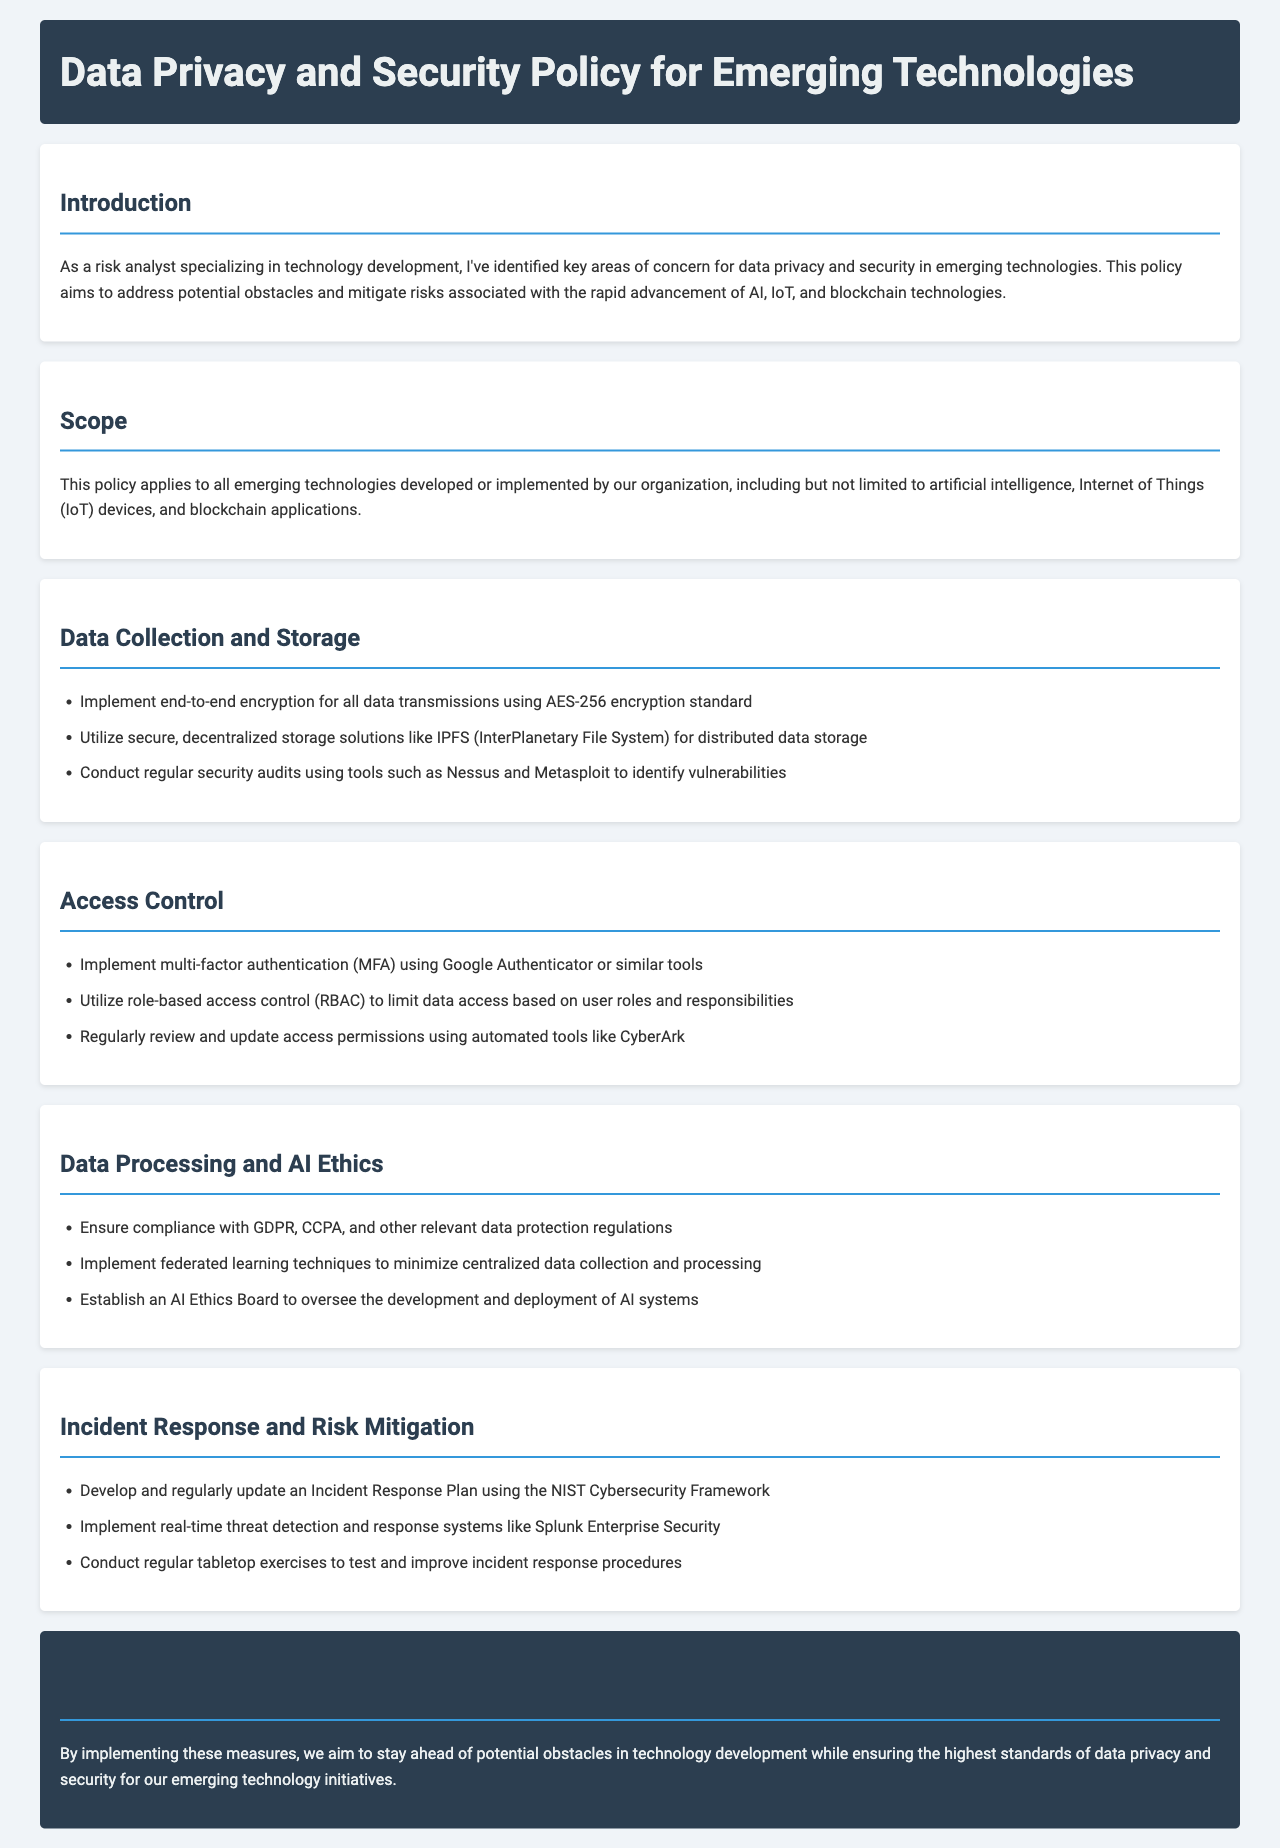what is the main purpose of this policy? The purpose of the policy is to address potential obstacles and mitigate risks associated with the rapid advancement of technologies.
Answer: address potential obstacles and mitigate risks which encryption standard should be used for data transmissions? The document specifies the AES-256 encryption standard for data transmissions.
Answer: AES-256 what types of technology does this policy apply to? The policy applies to technologies such as artificial intelligence, IoT devices, and blockchain applications.
Answer: artificial intelligence, IoT devices, blockchain applications what framework should be used for Incident Response Plans? The NIST Cybersecurity Framework should be used for Incident Response Plans.
Answer: NIST Cybersecurity Framework how often should access permissions be reviewed? The document suggests that access permissions should be reviewed regularly.
Answer: regularly who should oversee the development and deployment of AI systems? An AI Ethics Board is to oversee the development and deployment of AI systems.
Answer: AI Ethics Board what is one tool mentioned for security audits? The document mentions Nessus as a tool for security audits.
Answer: Nessus which technique minimizes centralized data collection in data processing? Federated learning techniques minimize centralized data collection in data processing.
Answer: Federated learning techniques what should be implemented for real-time threat detection? Splunk Enterprise Security should be implemented for real-time threat detection.
Answer: Splunk Enterprise Security 